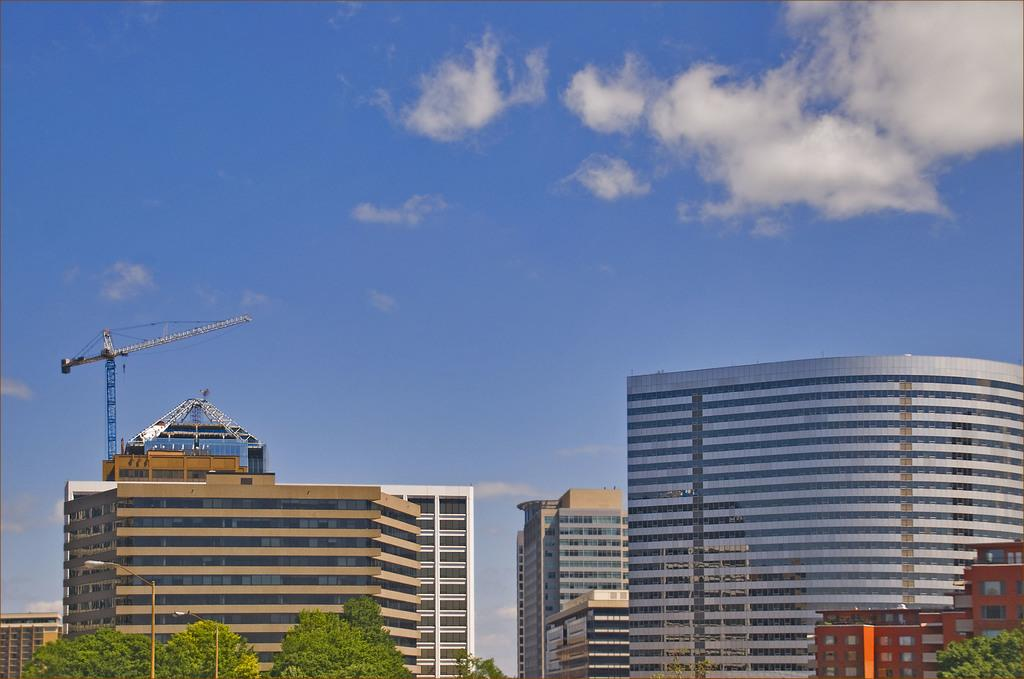What types of structures are visible in the image? There are many buildings in the image. What other elements can be seen in the image besides the buildings? There are trees in the image. What type of fruit is hanging from the cannon in the image? There is no cannon or fruit present in the image. 